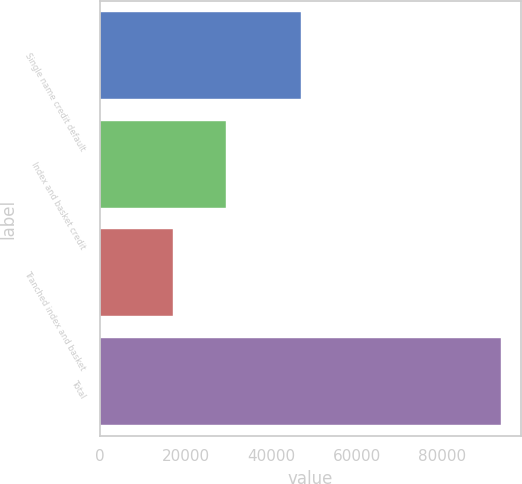<chart> <loc_0><loc_0><loc_500><loc_500><bar_chart><fcel>Single name credit default<fcel>Index and basket credit<fcel>Tranched index and basket<fcel>Total<nl><fcel>47045<fcel>29475<fcel>17109<fcel>93629<nl></chart> 